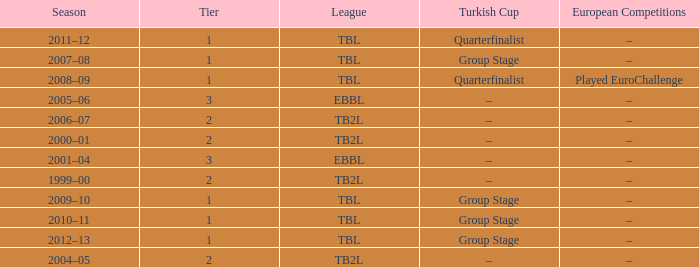Tier of 2, and a Season of 2000–01 is what European competitions? –. 